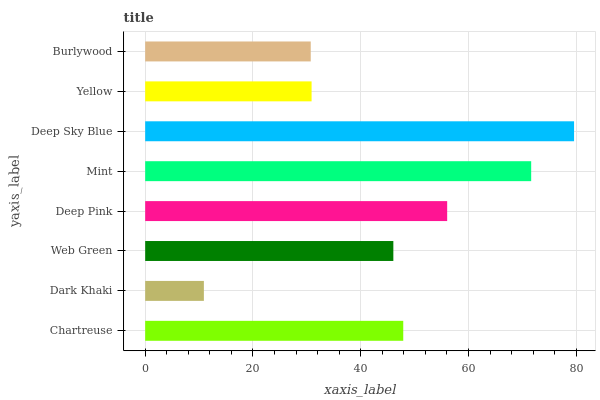Is Dark Khaki the minimum?
Answer yes or no. Yes. Is Deep Sky Blue the maximum?
Answer yes or no. Yes. Is Web Green the minimum?
Answer yes or no. No. Is Web Green the maximum?
Answer yes or no. No. Is Web Green greater than Dark Khaki?
Answer yes or no. Yes. Is Dark Khaki less than Web Green?
Answer yes or no. Yes. Is Dark Khaki greater than Web Green?
Answer yes or no. No. Is Web Green less than Dark Khaki?
Answer yes or no. No. Is Chartreuse the high median?
Answer yes or no. Yes. Is Web Green the low median?
Answer yes or no. Yes. Is Mint the high median?
Answer yes or no. No. Is Yellow the low median?
Answer yes or no. No. 